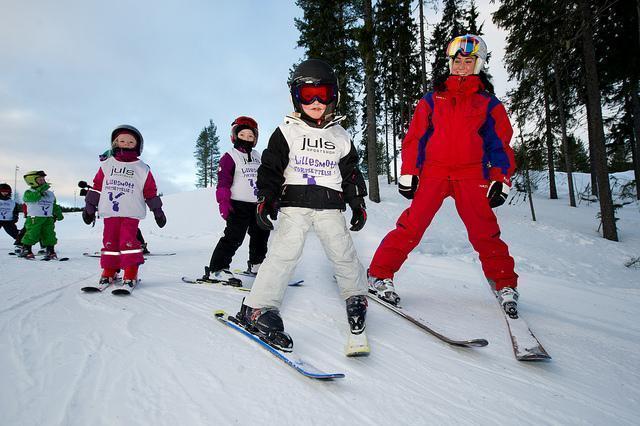Which person is the teacher?
From the following set of four choices, select the accurate answer to respond to the question.
Options: Black pants, green clothes, red clothes, white pants. Red clothes. 